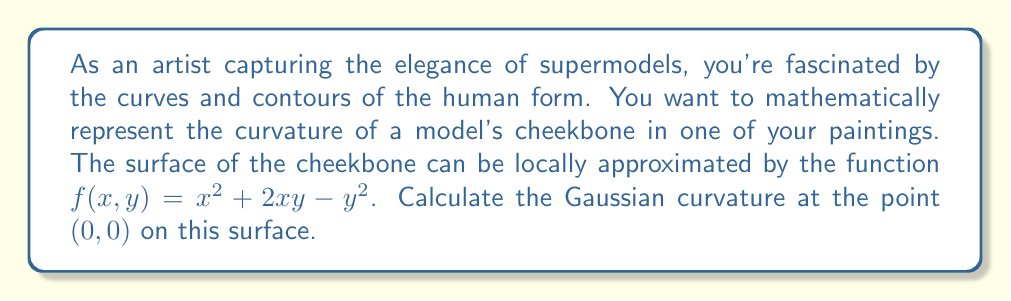What is the answer to this math problem? To determine the Gaussian curvature of the surface at a point, we need to use differential geometry. Here's how we can approach this problem:

1) First, we need to calculate the partial derivatives of $f(x,y)$:

   $f_x = 2x + 2y$
   $f_y = 2x - 2y$
   $f_{xx} = 2$
   $f_{xy} = 2$
   $f_{yy} = -2$

2) The Gaussian curvature K is given by the formula:

   $$K = \frac{f_{xx}f_{yy} - f_{xy}^2}{(1 + f_x^2 + f_y^2)^2}$$

3) At the point (0,0):

   $f_x(0,0) = 0$
   $f_y(0,0) = 0$
   $f_{xx}(0,0) = 2$
   $f_{xy}(0,0) = 2$
   $f_{yy}(0,0) = -2$

4) Substituting these values into the formula:

   $$K = \frac{(2)(-2) - (2)^2}{(1 + 0^2 + 0^2)^2}$$

5) Simplifying:

   $$K = \frac{-4 - 4}{1^2} = \frac{-8}{1} = -8$$

Therefore, the Gaussian curvature at the point (0,0) is -8.
Answer: The Gaussian curvature at the point (0,0) on the surface $f(x,y) = x^2 + 2xy - y^2$ is $-8$. 